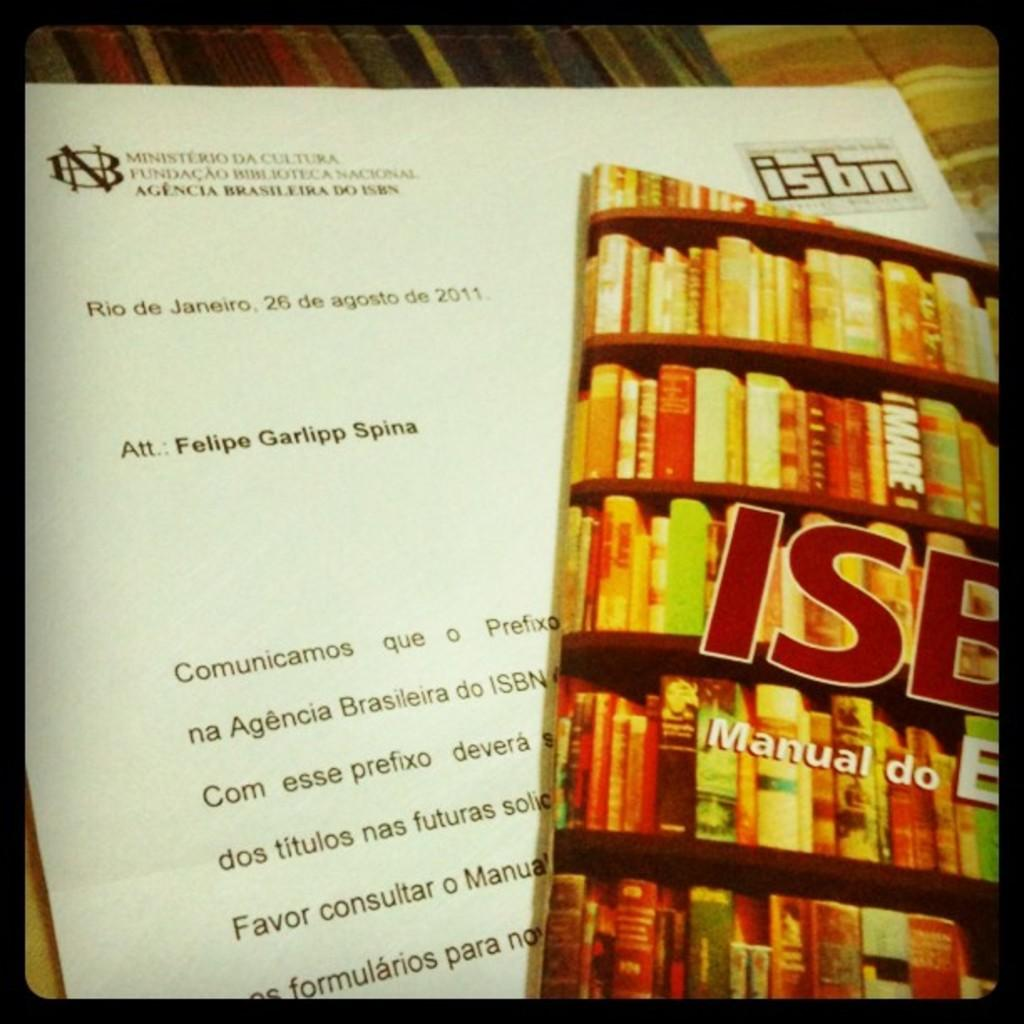<image>
Summarize the visual content of the image. a letter and book about ISBN att: Felipe 